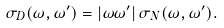<formula> <loc_0><loc_0><loc_500><loc_500>\sigma _ { D } ( \omega , \omega ^ { \prime } ) = | \omega \omega ^ { \prime } | \, \sigma _ { N } ( \omega , \omega ^ { \prime } ) .</formula> 